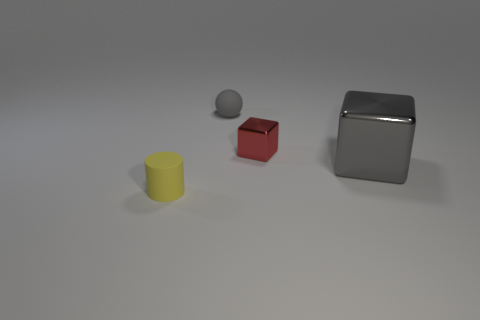What can you tell me about the texture characteristics of the objects? In the image, the objects exhibit differing texture characteristics. The gray cube appears to have a highly reflective, smooth surface, which could suggest a metallic material. The red and yellow objects have matte surfaces, indicating a less reflective quality, which could be a painted or plastic material. 